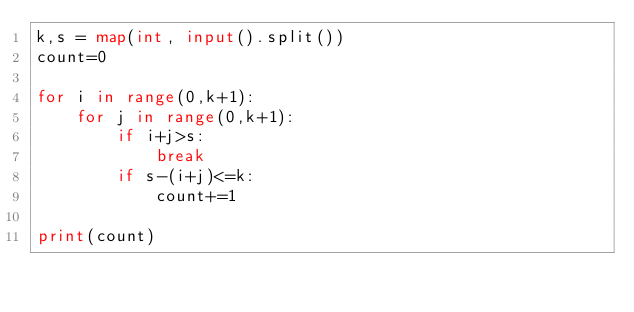<code> <loc_0><loc_0><loc_500><loc_500><_Python_>k,s = map(int, input().split())
count=0

for i in range(0,k+1):
    for j in range(0,k+1):
        if i+j>s:
            break
        if s-(i+j)<=k:
            count+=1
            
print(count)</code> 